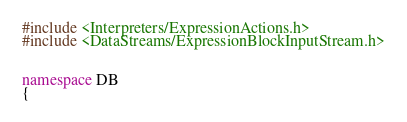<code> <loc_0><loc_0><loc_500><loc_500><_C++_>#include <Interpreters/ExpressionActions.h>
#include <DataStreams/ExpressionBlockInputStream.h>


namespace DB
{
</code> 